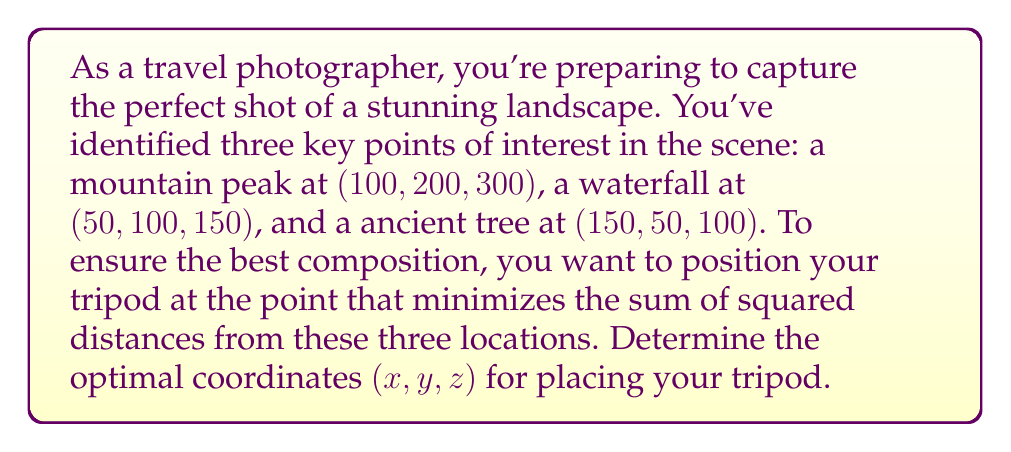Provide a solution to this math problem. To solve this problem, we need to use the concept of the centroid in three-dimensional space. The centroid is the arithmetic mean position of all the points in a set, and it minimizes the sum of squared distances from all points.

1. Calculate the centroid:
   The centroid $(x, y, z)$ is the average of the coordinates of all points.

   $$x = \frac{x_1 + x_2 + x_3}{3}$$
   $$y = \frac{y_1 + y_2 + y_3}{3}$$
   $$z = \frac{z_1 + z_2 + z_3}{3}$$

2. Substitute the given coordinates:
   Mountain peak: (100, 200, 300)
   Waterfall: (50, 100, 150)
   Ancient tree: (150, 50, 100)

   $$x = \frac{100 + 50 + 150}{3} = \frac{300}{3} = 100$$
   $$y = \frac{200 + 100 + 50}{3} = \frac{350}{3} \approx 116.67$$
   $$z = \frac{300 + 150 + 100}{3} = \frac{550}{3} \approx 183.33$$

3. Round the results to two decimal places for practical use.

The optimal position for the tripod is at the centroid of the three points of interest, which minimizes the sum of squared distances from these locations.
Answer: The optimal coordinates for placing the tripod are $(100.00, 116.67, 183.33)$. 